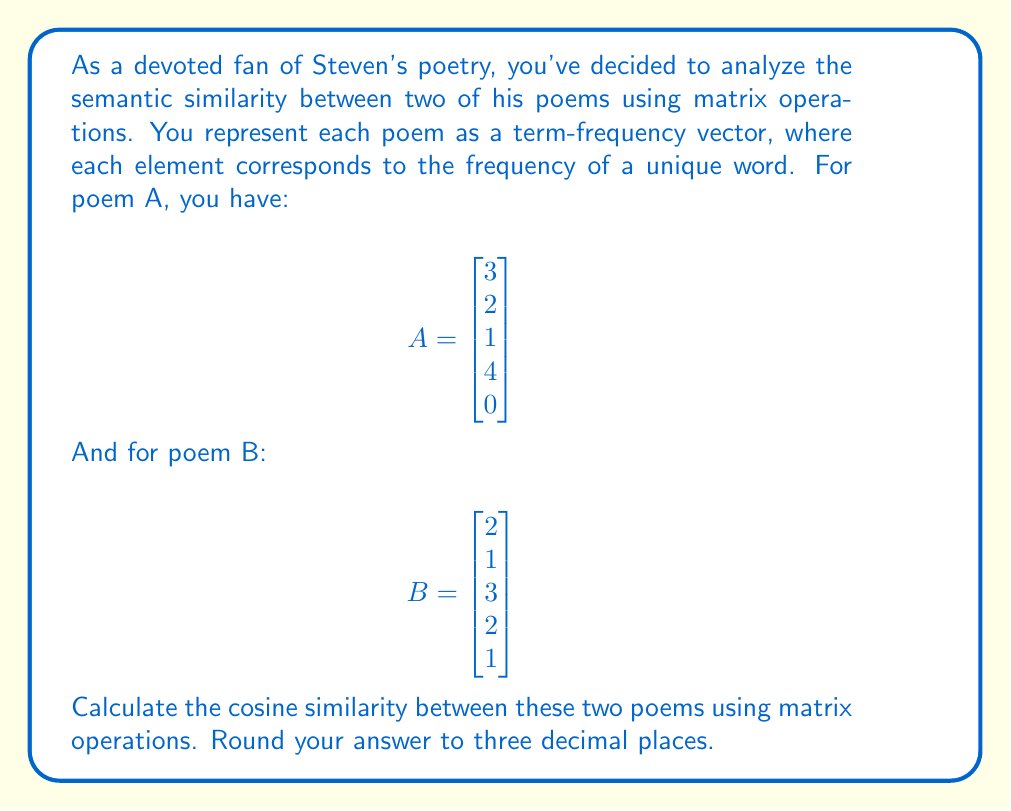Help me with this question. To calculate the cosine similarity between two vectors using matrix operations, we'll follow these steps:

1) The cosine similarity formula is:

   $$\text{cosine similarity} = \frac{A \cdot B}{\|A\| \|B\|}$$

   where $A \cdot B$ is the dot product and $\|A\|$, $\|B\|$ are the magnitudes of vectors A and B.

2) First, let's calculate the dot product $A \cdot B$:
   
   $$A \cdot B = A^T B = \begin{bmatrix} 3 & 2 & 1 & 4 & 0 \end{bmatrix} \begin{bmatrix} 2 \\ 1 \\ 3 \\ 2 \\ 1 \end{bmatrix} = 3(2) + 2(1) + 1(3) + 4(2) + 0(1) = 19$$

3) Now, let's calculate $\|A\|$:
   
   $$\|A\| = \sqrt{A^T A} = \sqrt{3^2 + 2^2 + 1^2 + 4^2 + 0^2} = \sqrt{30} \approx 5.477$$

4) Similarly for $\|B\|$:
   
   $$\|B\| = \sqrt{B^T B} = \sqrt{2^2 + 1^2 + 3^2 + 2^2 + 1^2} = \sqrt{19} \approx 4.359$$

5) Now we can substitute these values into our cosine similarity formula:

   $$\text{cosine similarity} = \frac{19}{5.477 \times 4.359} \approx 0.795$$

6) Rounding to three decimal places, we get 0.795.
Answer: 0.795 